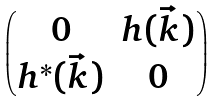<formula> <loc_0><loc_0><loc_500><loc_500>\begin{pmatrix} 0 & h ( \vec { k } ) \\ h ^ { * } ( \vec { k } ) & 0 \end{pmatrix}</formula> 